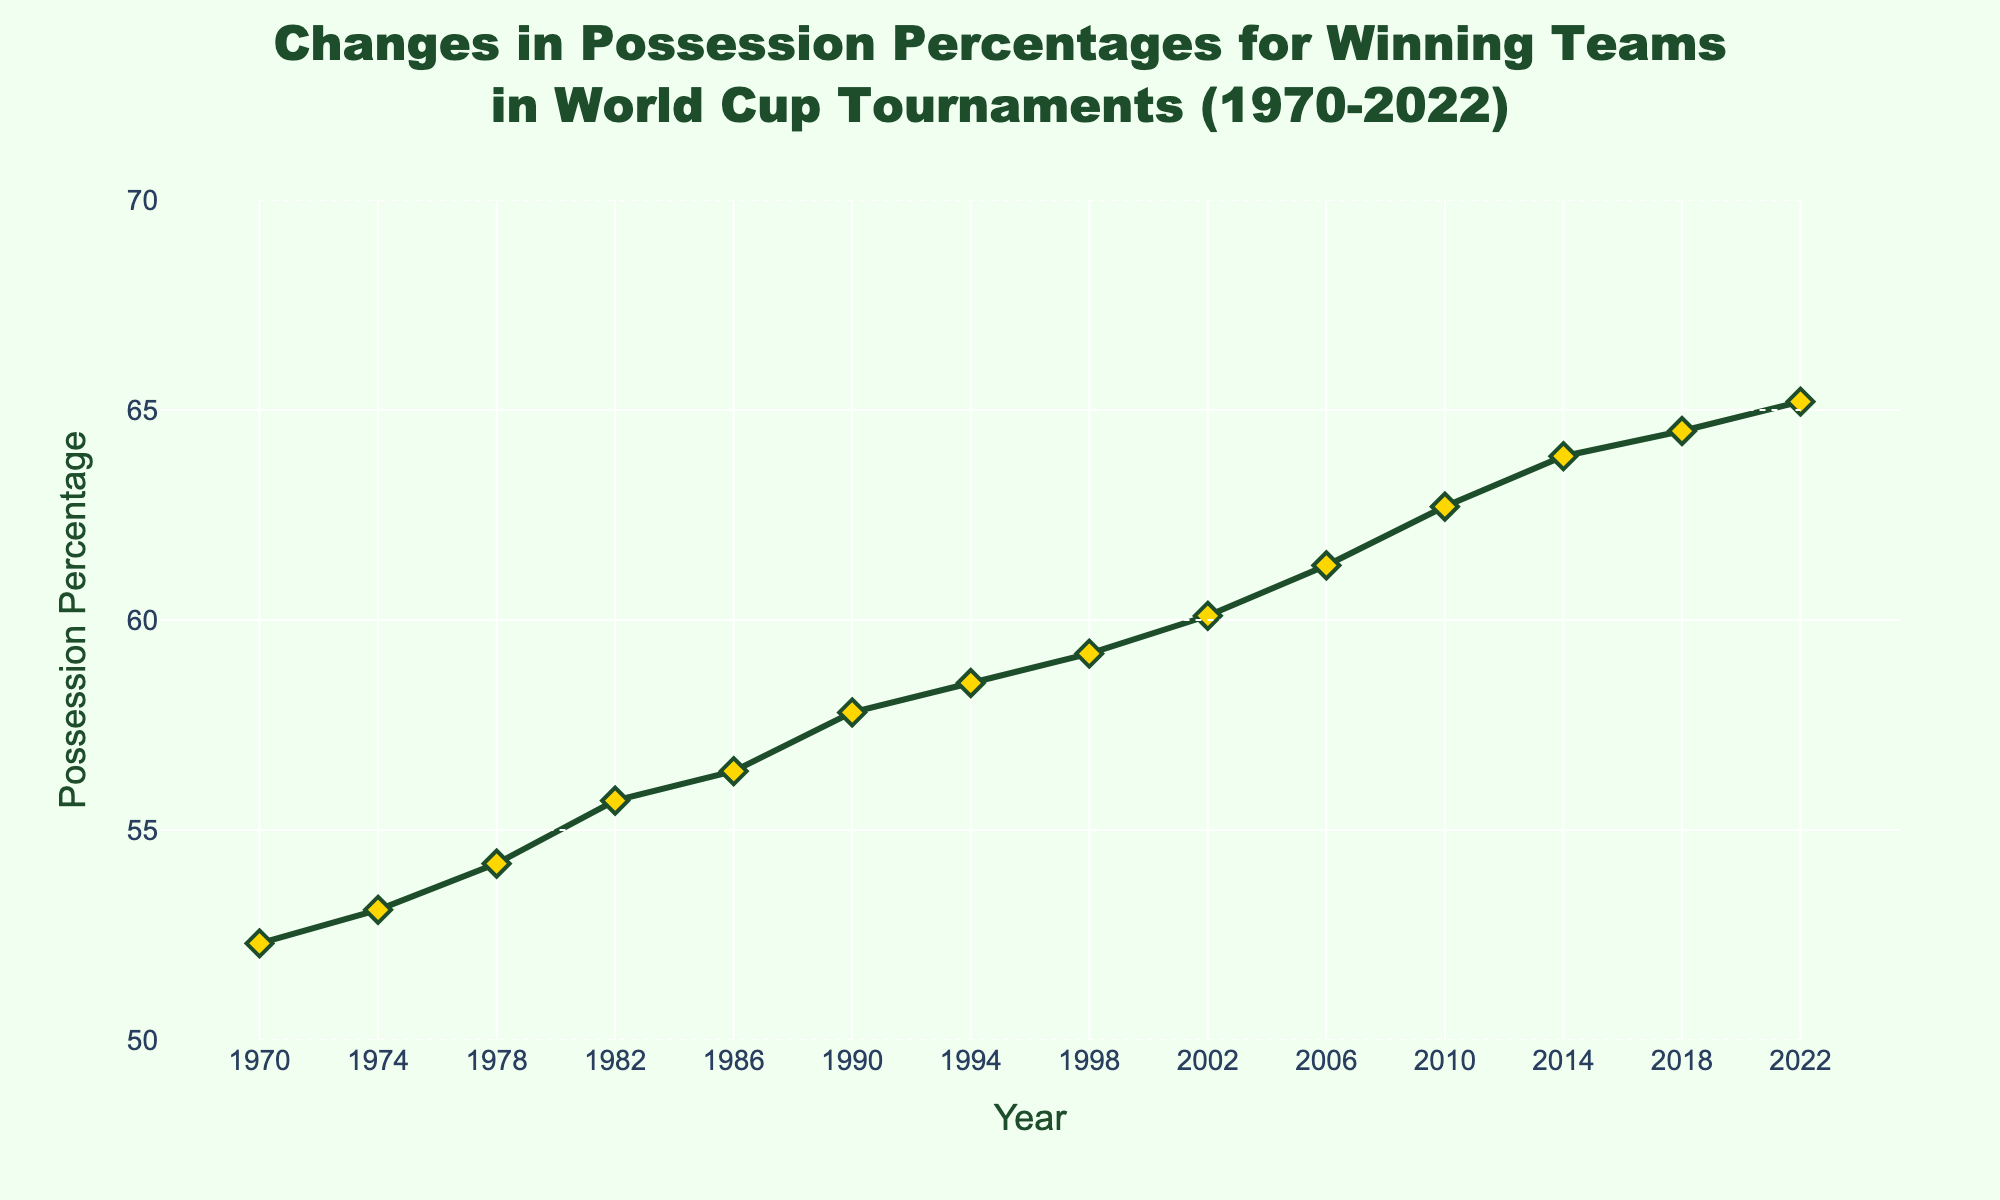What is the possession percentage for the winning team in the year 1990? Look at the data point corresponding to the year 1990 on the x-axis and read the possession percentage on the y-axis.
Answer: 57.8 How much did the possession percentage increase from 1970 to 2010? Note the possession percentages for 1970 (52.3) and 2010 (62.7). Subtract the possession percentage of 1970 from that of 2010: 62.7 - 52.3.
Answer: 10.4 What is the average possession percentage for winning teams from 1970 to 2022? Add all the possession percentages from 1970 to 2022 and divide by the number of years. (52.3 + 53.1 + 54.2 + 55.7 + 56.4 + 57.8 + 58.5 + 59.2 + 60.1 + 61.3 + 62.7 + 63.9 + 64.5 + 65.2) / 14.
Answer: 59.2 Did the possession percentage ever decrease in any World Cup tournament from 1970 to 2022? Check for any points in the line chart where a later year's possession percentage is less than an earlier year's. No such points exist; the trend is steadily increasing.
Answer: No Which year saw the highest possession percentage for winning teams? Identify the highest point on the y-axis and note the corresponding year on the x-axis.
Answer: 2022 Between 2006 and 2010, which year had a higher possession percentage? Compare the possession percentages for 2006 (61.3) and 2010 (62.7). 2010 has a higher value.
Answer: 2010 By how much did the possession percentage change between the years 1974 and 1994? Note the possession percentages for 1974 (53.1) and 1994 (58.5). Subtract the earlier year's value from the later year's: 58.5 - 53.1.
Answer: 5.4 What is the difference in possession percentage between the first year and the last year? Note the possession percentages for 1970 (52.3) and 2022 (65.2). Subtract the percentage for 1970 from the percentage for 2022: 65.2 - 52.3.
Answer: 12.9 How often do the possession percentages increase by more than 1% from one tournament to the next? Evaluate each consecutive pair of years to check if the difference exceeds 1%. Several such pairs exist (e.g., 1978-1982: 1.5, 1990-1994: 0.7, etc.).
Answer: Several times 